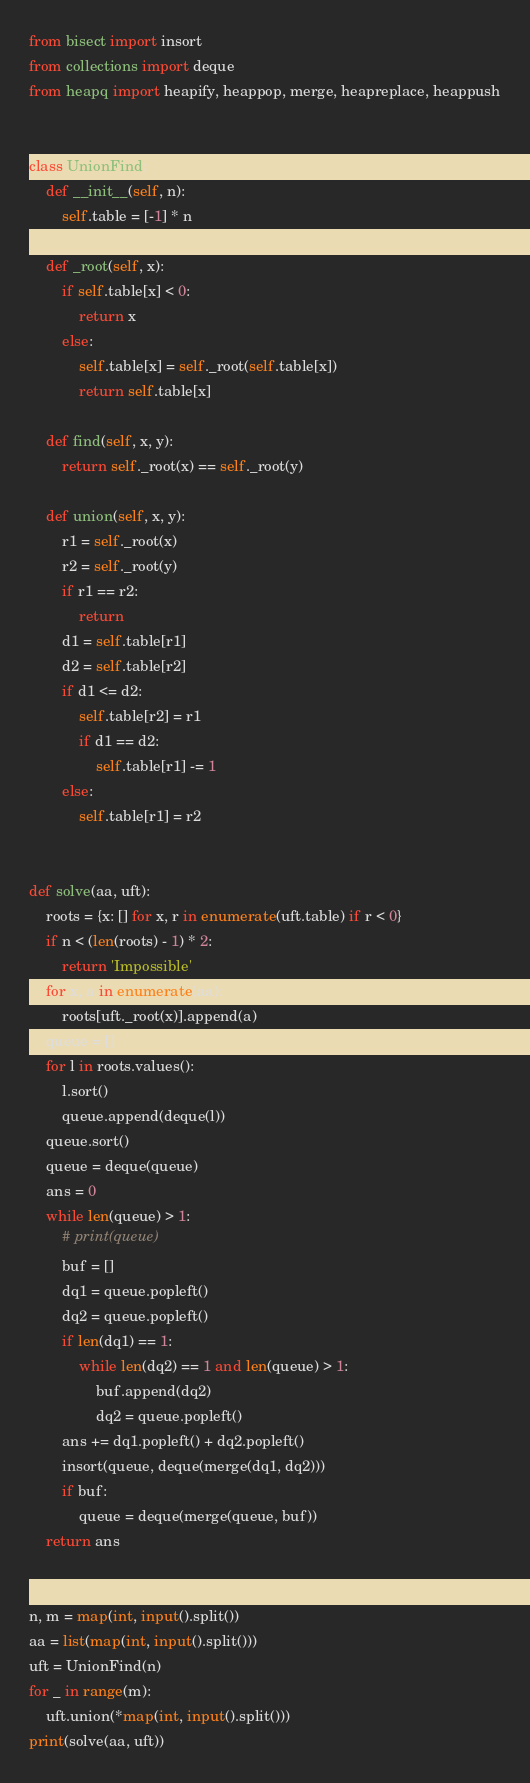Convert code to text. <code><loc_0><loc_0><loc_500><loc_500><_Python_>from bisect import insort
from collections import deque
from heapq import heapify, heappop, merge, heapreplace, heappush


class UnionFind:
    def __init__(self, n):
        self.table = [-1] * n

    def _root(self, x):
        if self.table[x] < 0:
            return x
        else:
            self.table[x] = self._root(self.table[x])
            return self.table[x]

    def find(self, x, y):
        return self._root(x) == self._root(y)

    def union(self, x, y):
        r1 = self._root(x)
        r2 = self._root(y)
        if r1 == r2:
            return
        d1 = self.table[r1]
        d2 = self.table[r2]
        if d1 <= d2:
            self.table[r2] = r1
            if d1 == d2:
                self.table[r1] -= 1
        else:
            self.table[r1] = r2


def solve(aa, uft):
    roots = {x: [] for x, r in enumerate(uft.table) if r < 0}
    if n < (len(roots) - 1) * 2:
        return 'Impossible'
    for x, a in enumerate(aa):
        roots[uft._root(x)].append(a)
    queue = []
    for l in roots.values():
        l.sort()
        queue.append(deque(l))
    queue.sort()
    queue = deque(queue)
    ans = 0
    while len(queue) > 1:
        # print(queue)
        buf = []
        dq1 = queue.popleft()
        dq2 = queue.popleft()
        if len(dq1) == 1:
            while len(dq2) == 1 and len(queue) > 1:
                buf.append(dq2)
                dq2 = queue.popleft()
        ans += dq1.popleft() + dq2.popleft()
        insort(queue, deque(merge(dq1, dq2)))
        if buf:
            queue = deque(merge(queue, buf))
    return ans


n, m = map(int, input().split())
aa = list(map(int, input().split()))
uft = UnionFind(n)
for _ in range(m):
    uft.union(*map(int, input().split()))
print(solve(aa, uft))
</code> 